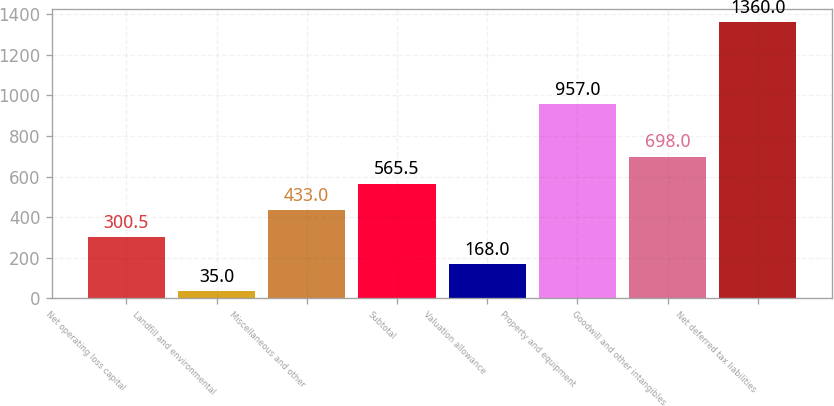Convert chart to OTSL. <chart><loc_0><loc_0><loc_500><loc_500><bar_chart><fcel>Net operating loss capital<fcel>Landfill and environmental<fcel>Miscellaneous and other<fcel>Subtotal<fcel>Valuation allowance<fcel>Property and equipment<fcel>Goodwill and other intangibles<fcel>Net deferred tax liabilities<nl><fcel>300.5<fcel>35<fcel>433<fcel>565.5<fcel>168<fcel>957<fcel>698<fcel>1360<nl></chart> 